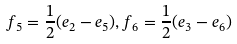<formula> <loc_0><loc_0><loc_500><loc_500>f _ { 5 } = \frac { 1 } { 2 } ( e _ { 2 } - e _ { 5 } ) , f _ { 6 } = \frac { 1 } { 2 } ( e _ { 3 } - e _ { 6 } )</formula> 